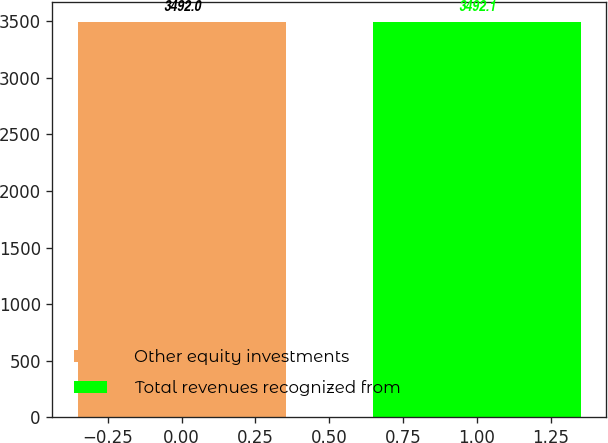Convert chart to OTSL. <chart><loc_0><loc_0><loc_500><loc_500><bar_chart><fcel>Other equity investments<fcel>Total revenues recognized from<nl><fcel>3492<fcel>3492.1<nl></chart> 